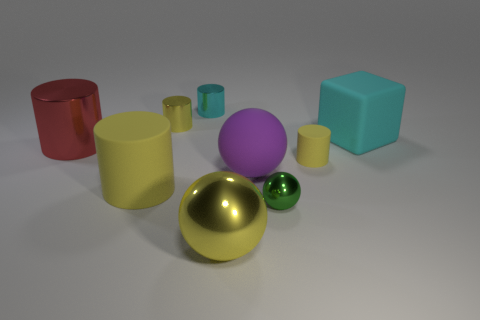Can you tell me what kind of light is being cast on the objects, and what that suggests about the environment? The objects are illuminated by a soft, diffused light, which suggests they are in a setting with either natural light on a cloudy day or ambient artificial light. The absence of sharp shadows indicates that the light source is not extremely close to the objects. 